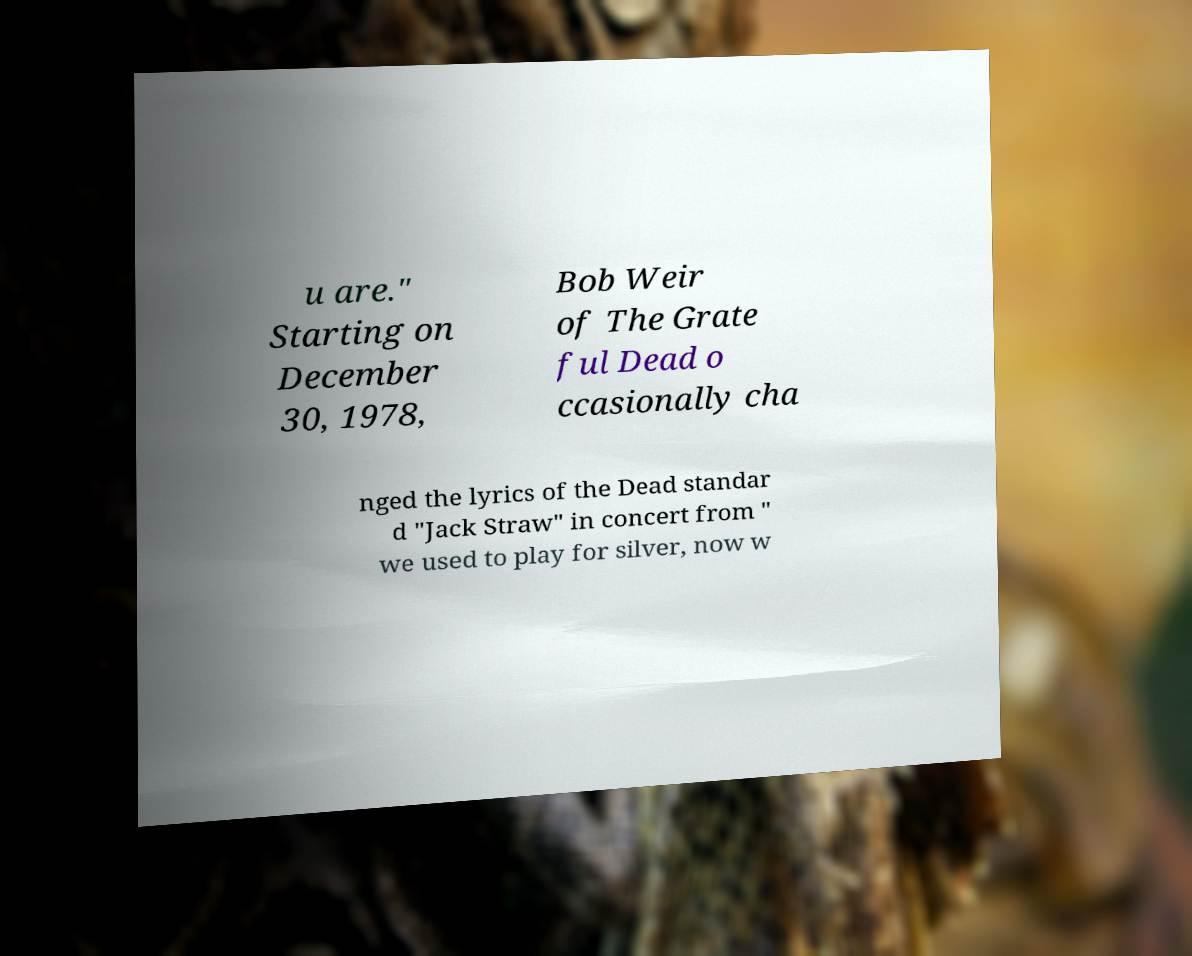Could you extract and type out the text from this image? u are." Starting on December 30, 1978, Bob Weir of The Grate ful Dead o ccasionally cha nged the lyrics of the Dead standar d "Jack Straw" in concert from " we used to play for silver, now w 